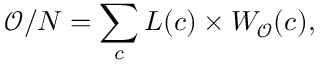<formula> <loc_0><loc_0><loc_500><loc_500>\mathcal { O } / N = \sum _ { c } L ( c ) \times W _ { \mathcal { O } } ( c ) ,</formula> 